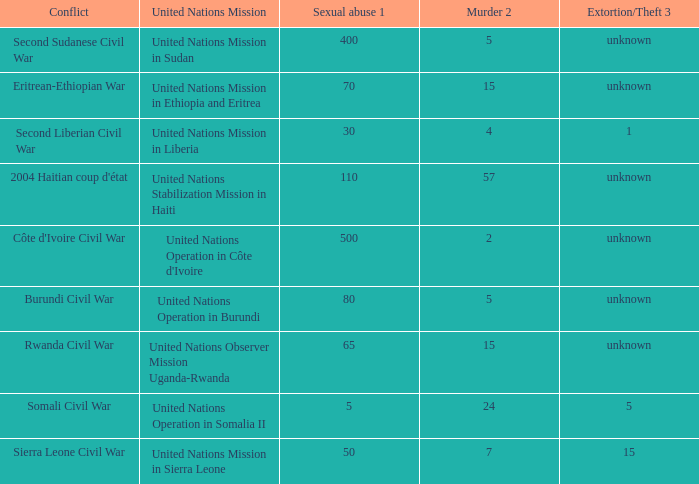What is the sexual abuse rate where the conflict is the Second Sudanese Civil War? 400.0. 